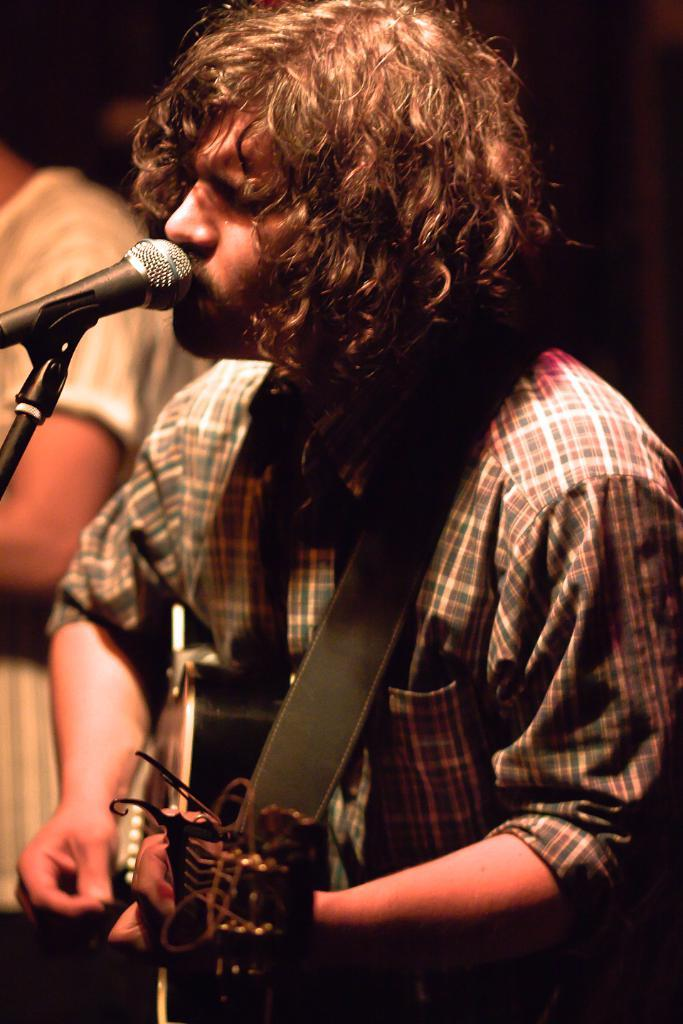What is the main subject of the image? The main subject of the image is a man. What is the man holding in his hand? The man is holding a guitar in his hand. What is the title of the song that the man is playing on the guitar in the image? There is no information about a song or its title in the image. 